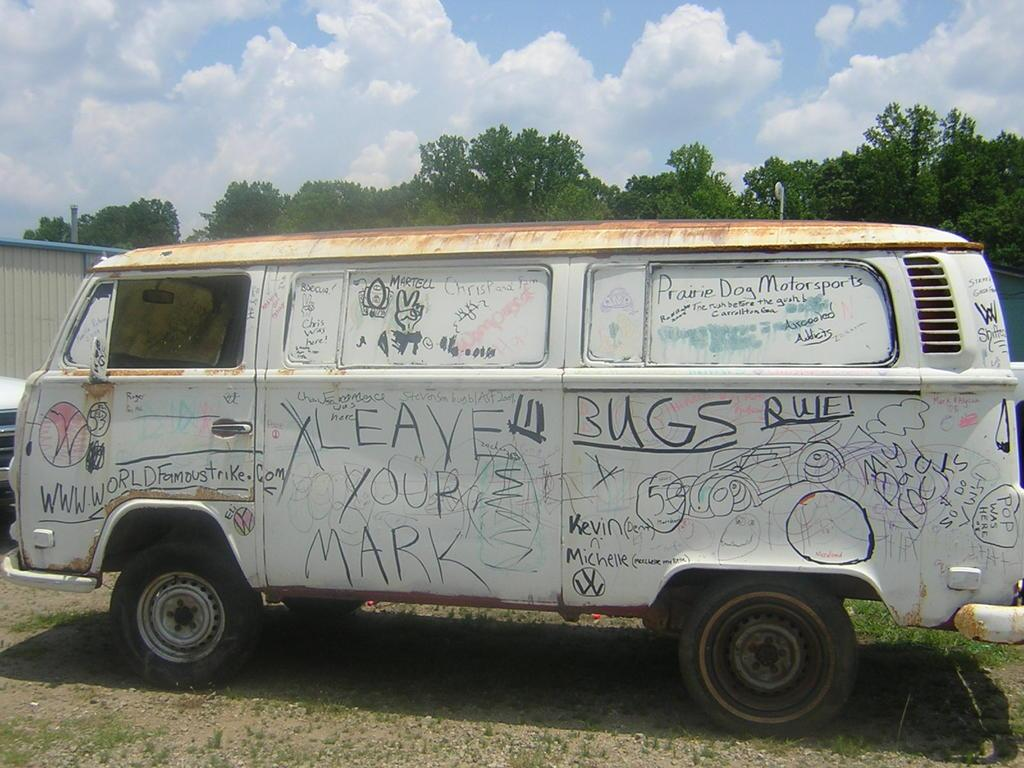What type of vehicle is in the picture? There is a van in the picture. What can be seen on the van's exterior? The van has paintings and quotations on it. Can you describe the condition of the van? The van appears to be damaged. What is visible in the background of the image? There are many trees behind the van. Where is the pump located in the image? There is no pump present in the image. Can you describe the cattle in the image? There are no cattle present in the image. 